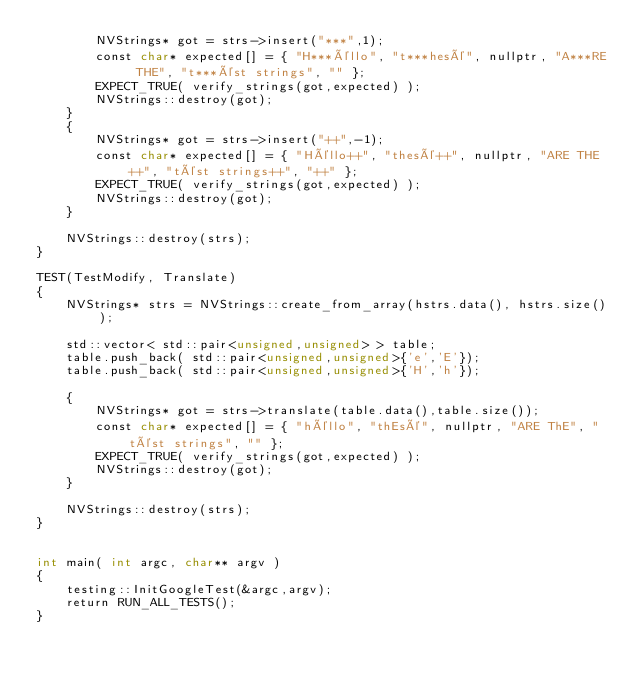<code> <loc_0><loc_0><loc_500><loc_500><_Cuda_>        NVStrings* got = strs->insert("***",1);
        const char* expected[] = { "H***éllo", "t***hesé", nullptr, "A***RE THE", "t***ést strings", "" };
        EXPECT_TRUE( verify_strings(got,expected) );
        NVStrings::destroy(got);
    }
    {
        NVStrings* got = strs->insert("++",-1);
        const char* expected[] = { "Héllo++", "thesé++", nullptr, "ARE THE++", "tést strings++", "++" };
        EXPECT_TRUE( verify_strings(got,expected) );
        NVStrings::destroy(got);
    }

    NVStrings::destroy(strs);
}

TEST(TestModify, Translate)
{
    NVStrings* strs = NVStrings::create_from_array(hstrs.data(), hstrs.size());

    std::vector< std::pair<unsigned,unsigned> > table;
    table.push_back( std::pair<unsigned,unsigned>{'e','E'});
    table.push_back( std::pair<unsigned,unsigned>{'H','h'});

    {
        NVStrings* got = strs->translate(table.data(),table.size());
        const char* expected[] = { "héllo", "thEsé", nullptr, "ARE ThE", "tést strings", "" };
        EXPECT_TRUE( verify_strings(got,expected) );
        NVStrings::destroy(got);
    }

    NVStrings::destroy(strs);
}


int main( int argc, char** argv )
{
    testing::InitGoogleTest(&argc,argv);
    return RUN_ALL_TESTS();
}</code> 